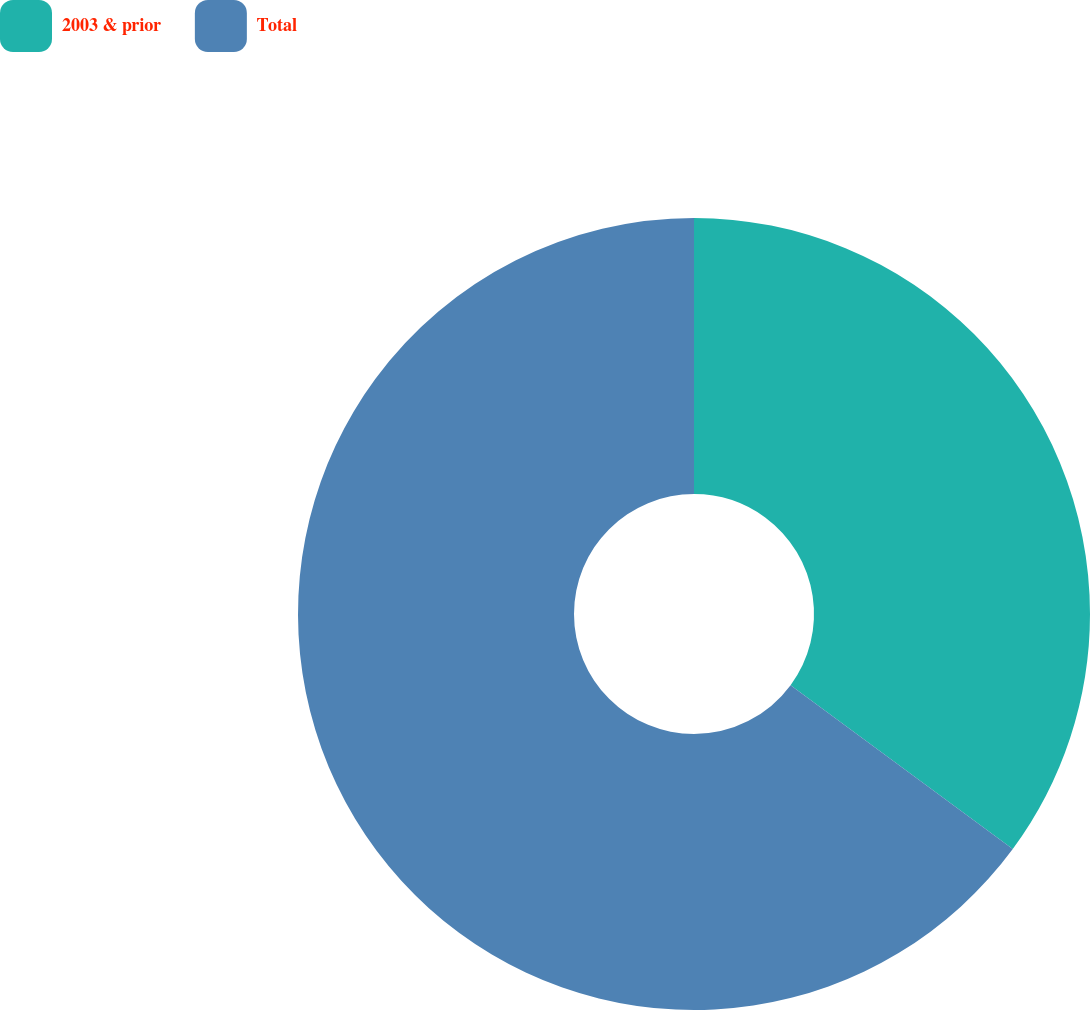Convert chart. <chart><loc_0><loc_0><loc_500><loc_500><pie_chart><fcel>2003 & prior<fcel>Total<nl><fcel>35.11%<fcel>64.89%<nl></chart> 